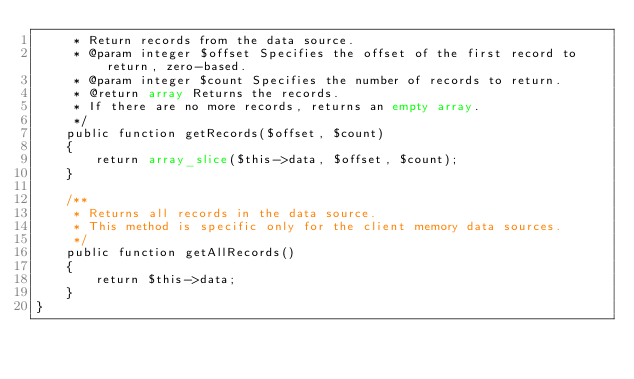Convert code to text. <code><loc_0><loc_0><loc_500><loc_500><_PHP_>     * Return records from the data source.
     * @param integer $offset Specifies the offset of the first record to return, zero-based.
     * @param integer $count Specifies the number of records to return.
     * @return array Returns the records.
     * If there are no more records, returns an empty array.
     */
    public function getRecords($offset, $count)
    {
        return array_slice($this->data, $offset, $count);
    }

    /**
     * Returns all records in the data source.
     * This method is specific only for the client memory data sources.
     */
    public function getAllRecords()
    {
        return $this->data;
    }
}
</code> 